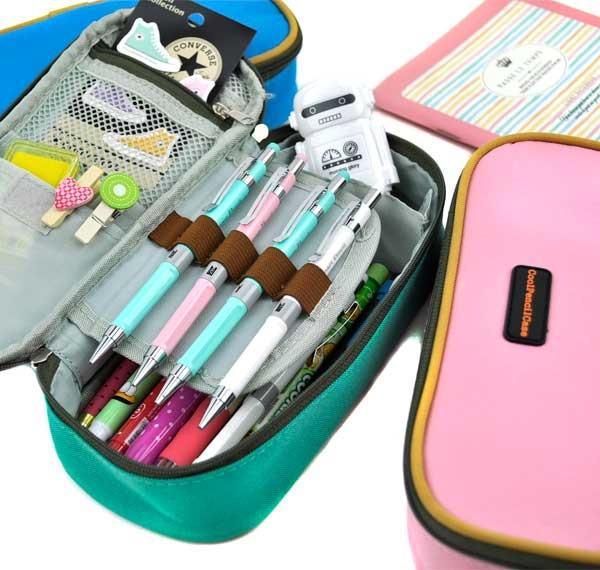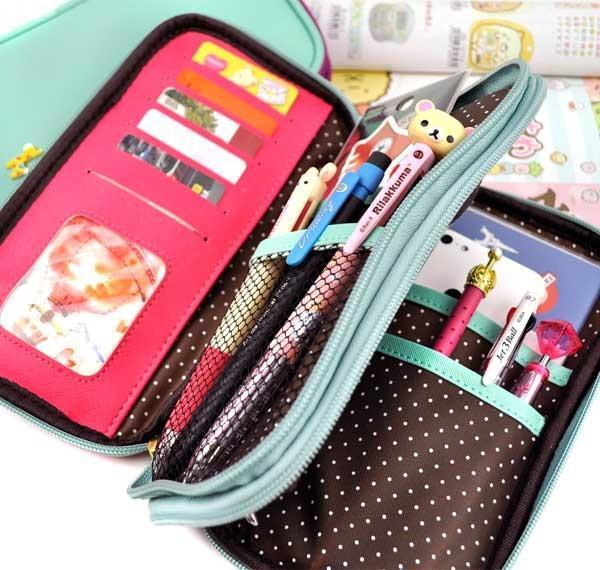The first image is the image on the left, the second image is the image on the right. Evaluate the accuracy of this statement regarding the images: "The left image includes a pair of eyeglasses at least partly visible.". Is it true? Answer yes or no. No. 